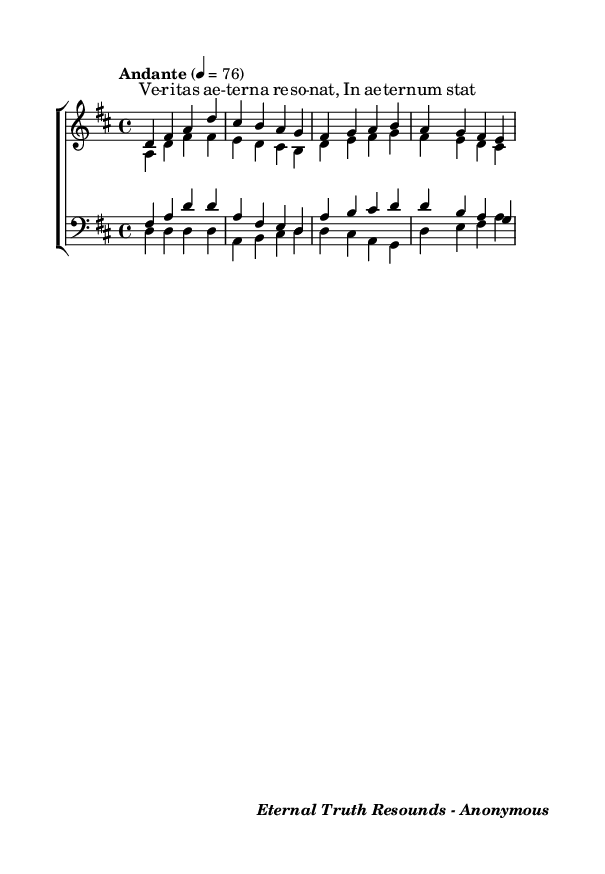What is the key signature of this music? The key signature is indicated by the presence of two sharps (F# and C#) in the music, which is characteristic of the D major scale.
Answer: D major What is the time signature of this music? The time signature is indicated at the beginning of the score and is written as 4/4, meaning there are four beats in each measure and the quarter note gets one beat.
Answer: 4/4 What is the tempo marking for this piece? The tempo marking, found above the staff in the score, indicates the speed of the music and is written as "Andante" at a rate of 76 beats per minute.
Answer: Andante How many vocal parts are present in this choral arrangement? By looking at the score, there are four parts explicitly stated including sopranos, altos, tenors, and basses, which makes a total of four vocal parts.
Answer: Four What text is set to the music? The lyrics provided are “Ve -- ri -- tas ae -- ter -- na re -- so -- nat, In ae -- ter -- num stat,” which is the text set to music in this arrangement.
Answer: Ve -- ri -- tas ae -- ter -- na re -- so -- nat, In ae -- ter -- num stat What is the style of the arrangement based on its text? The arrangement is based on an ancient religious text, which often reflects the choral tradition found in sacred music or liturgical settings. This style indicates a religious or sacred music type.
Answer: Religious 